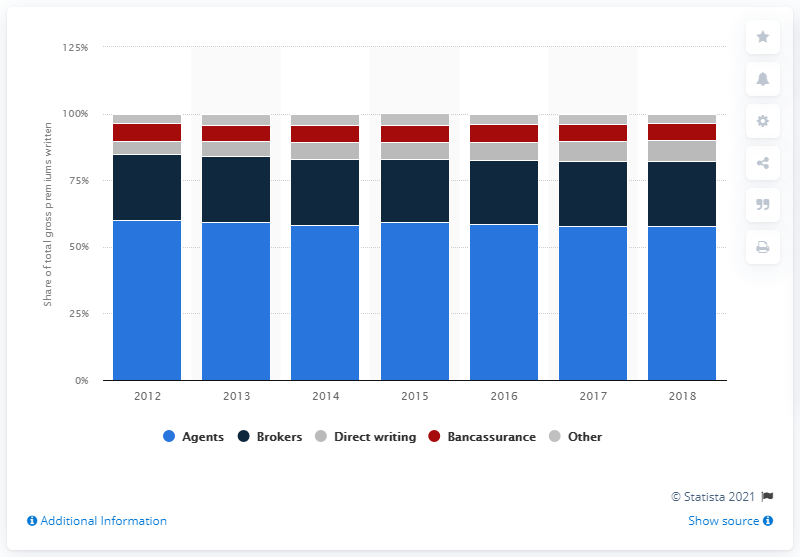Highlight a few significant elements in this photo. In 2018, insurance agents distributed 58% of the total non-life insurance premiums written in Germany. 